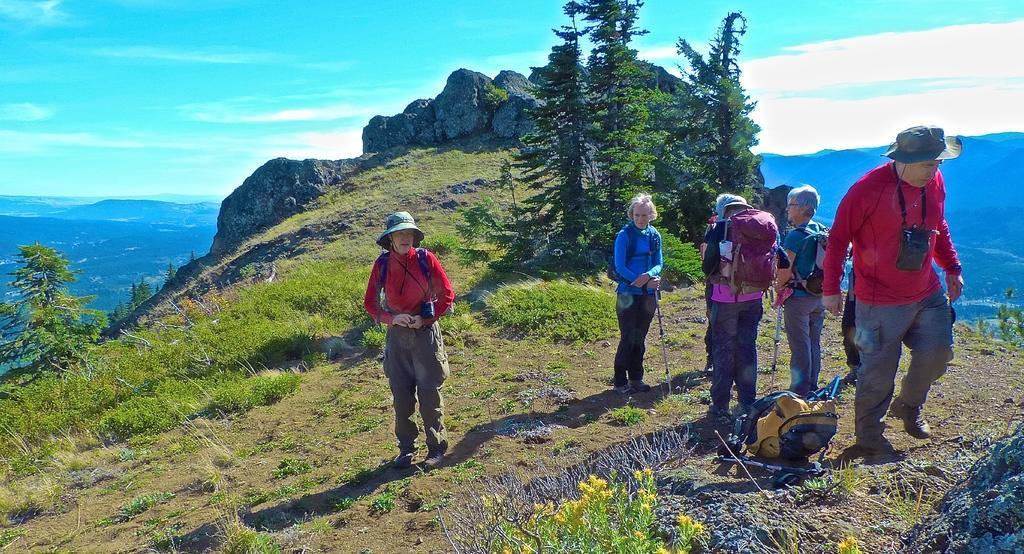Can you describe this image briefly? In the center of the image we can see a few people are standing and they are in different costumes. Among them, we can see a few people are wearing hats, few people are wearing backpacks and a few people are holding some objects. In the background, we can see the sky, clouds, hills, rocks, trees, plants, one bag and a few other objects. 